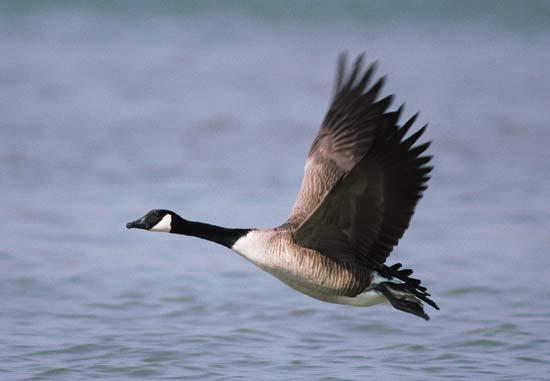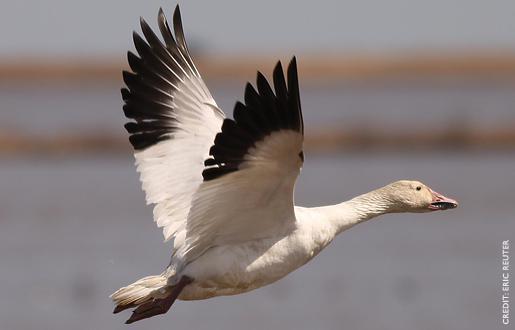The first image is the image on the left, the second image is the image on the right. Examine the images to the left and right. Is the description "Two geese are floating on the water in the image on the left." accurate? Answer yes or no. No. 